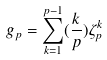<formula> <loc_0><loc_0><loc_500><loc_500>g _ { p } = \sum _ { k = 1 } ^ { p - 1 } ( \frac { k } { p } ) \zeta _ { p } ^ { k }</formula> 